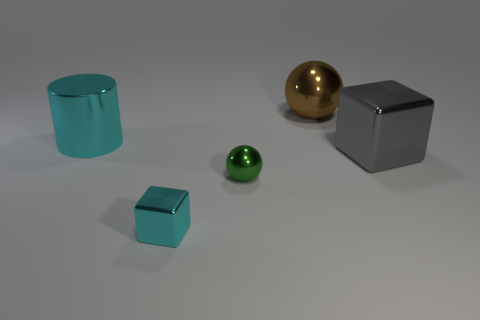Do the metal thing in front of the green shiny thing and the brown metal thing have the same size?
Give a very brief answer. No. The large object that is in front of the large ball and on the right side of the large cyan object is what color?
Your response must be concise. Gray. How many things are small shiny cubes or large gray shiny things to the right of the cylinder?
Make the answer very short. 2. The ball that is in front of the large brown metal sphere that is to the right of the cyan shiny object behind the tiny cube is made of what material?
Make the answer very short. Metal. Is there any other thing that is the same material as the big brown ball?
Your response must be concise. Yes. There is a metal cube that is on the left side of the large shiny sphere; is it the same color as the large cube?
Offer a very short reply. No. What number of blue things are either tiny balls or big metal cylinders?
Provide a short and direct response. 0. What number of other things are there of the same shape as the green object?
Give a very brief answer. 1. Do the big cyan cylinder and the cyan cube have the same material?
Give a very brief answer. Yes. There is a thing that is behind the big gray object and on the left side of the big sphere; what material is it?
Your response must be concise. Metal. 